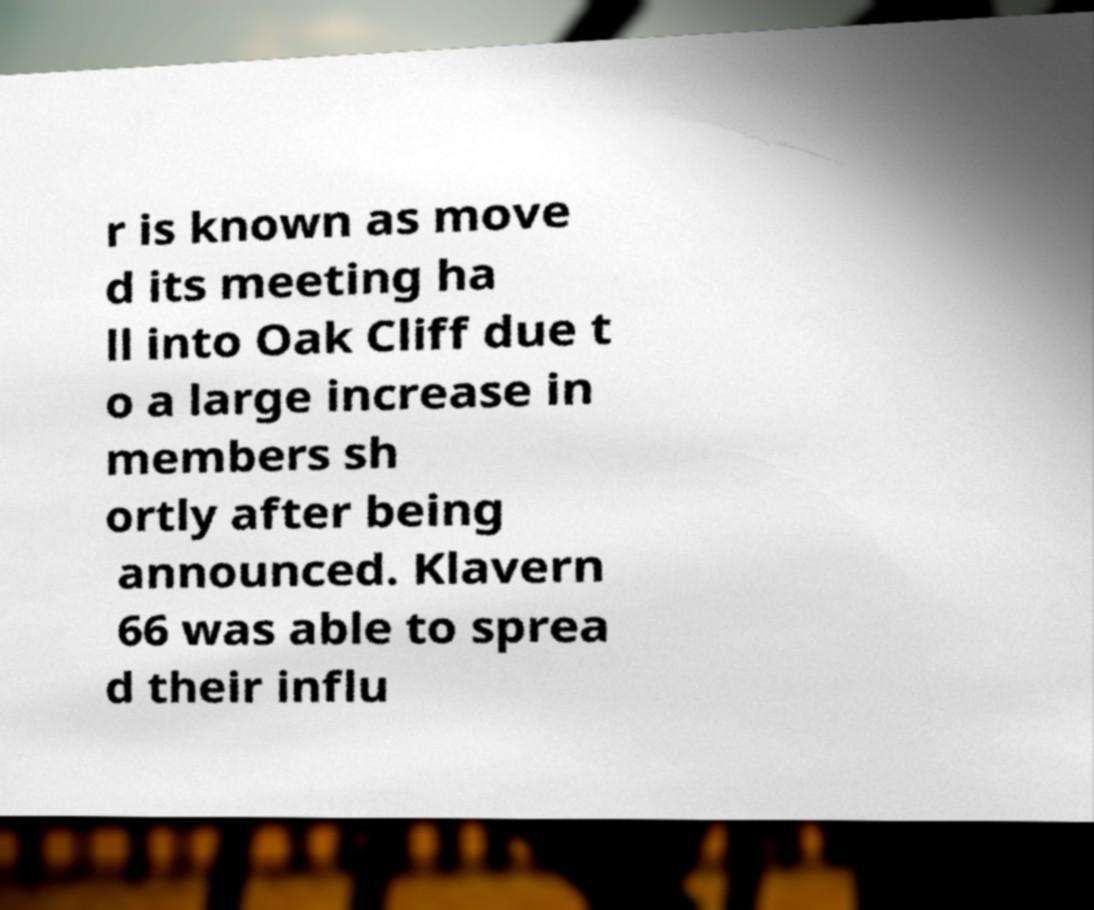Please identify and transcribe the text found in this image. r is known as move d its meeting ha ll into Oak Cliff due t o a large increase in members sh ortly after being announced. Klavern 66 was able to sprea d their influ 